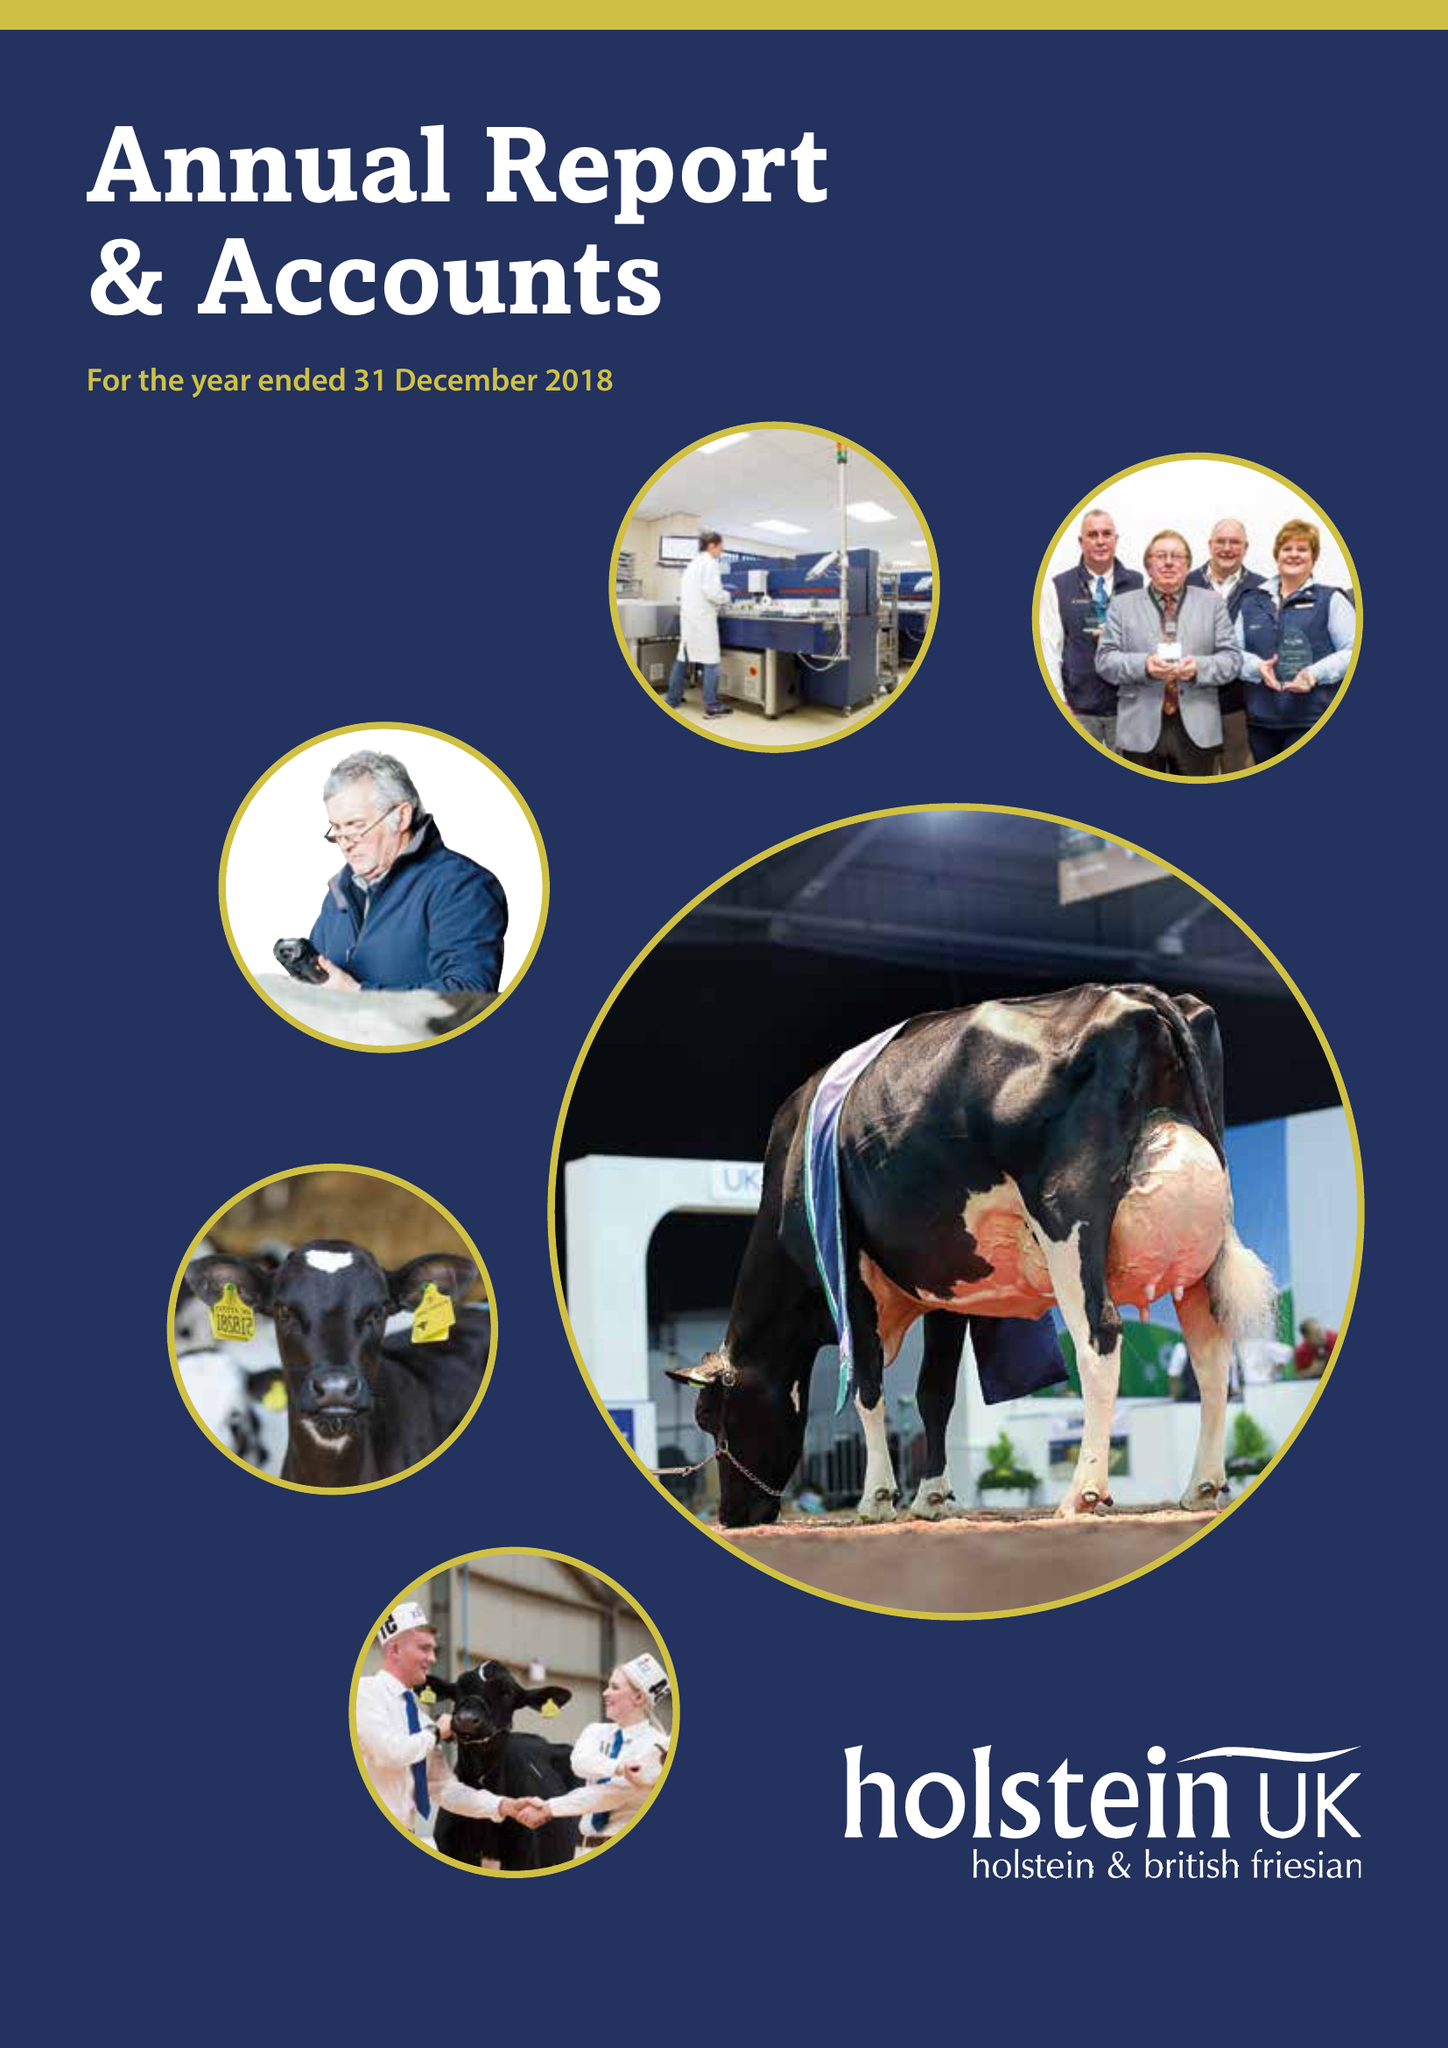What is the value for the spending_annually_in_british_pounds?
Answer the question using a single word or phrase. 10497998.00 